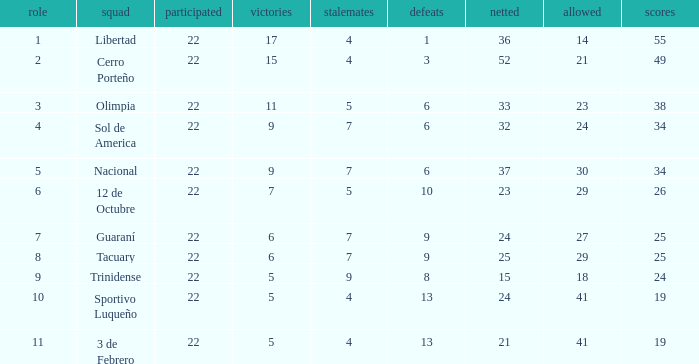What is the value scored when there were 19 points for the team 3 de Febrero? 21.0. 